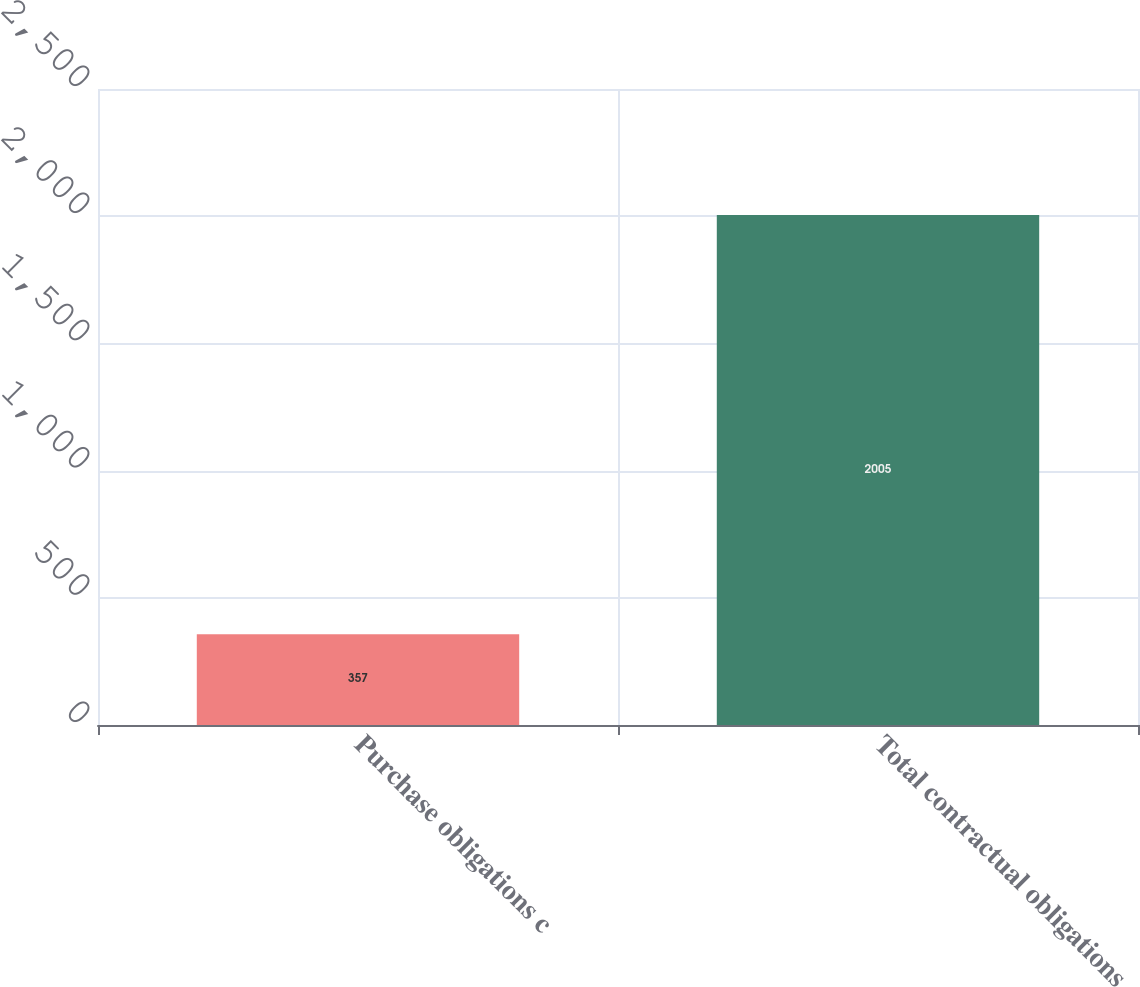Convert chart to OTSL. <chart><loc_0><loc_0><loc_500><loc_500><bar_chart><fcel>Purchase obligations c<fcel>Total contractual obligations<nl><fcel>357<fcel>2005<nl></chart> 